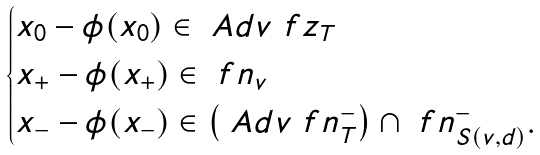Convert formula to latex. <formula><loc_0><loc_0><loc_500><loc_500>\begin{cases} x _ { 0 } - \phi ( x _ { 0 } ) \in \ A d v \ f z _ { T } \\ x _ { + } - \phi ( x _ { + } ) \in \ f n _ { v } \\ x _ { - } - \phi ( x _ { - } ) \in \left ( \ A d v \ f n _ { T } ^ { - } \right ) \cap \ f n ^ { - } _ { S ( v , d ) } . \end{cases}</formula> 